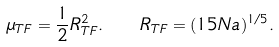<formula> <loc_0><loc_0><loc_500><loc_500>\mu _ { T F } = \frac { 1 } { 2 } R _ { T F } ^ { 2 } . \quad R _ { T F } = ( 1 5 N a ) ^ { 1 / 5 } .</formula> 